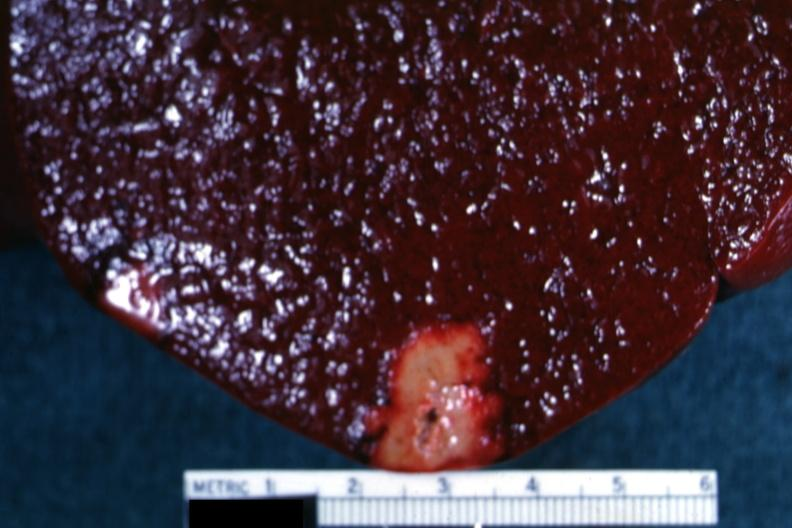where is this part in?
Answer the question using a single word or phrase. Spleen 